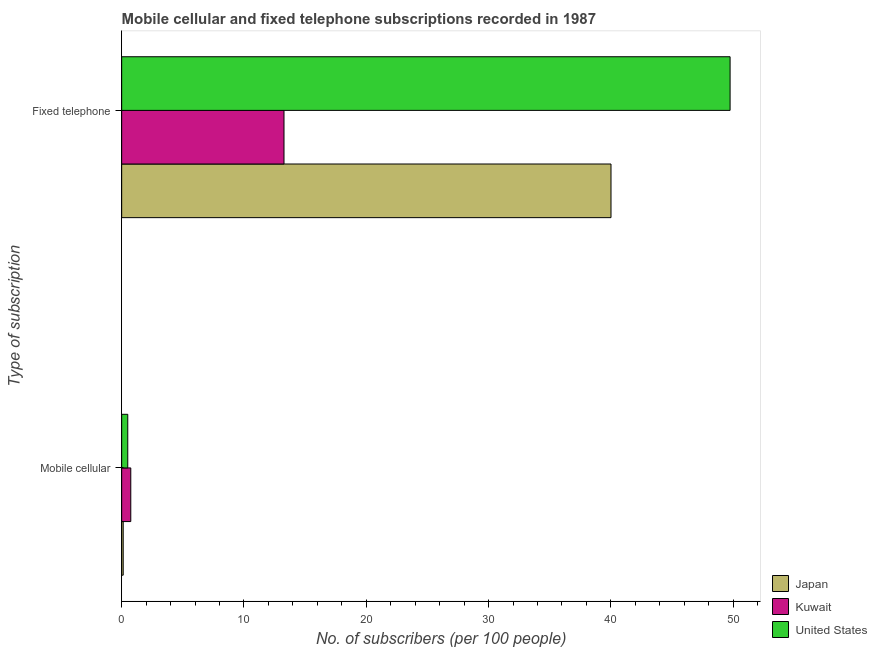How many different coloured bars are there?
Keep it short and to the point. 3. How many bars are there on the 1st tick from the bottom?
Your answer should be compact. 3. What is the label of the 1st group of bars from the top?
Make the answer very short. Fixed telephone. What is the number of mobile cellular subscribers in Kuwait?
Give a very brief answer. 0.74. Across all countries, what is the maximum number of mobile cellular subscribers?
Make the answer very short. 0.74. Across all countries, what is the minimum number of mobile cellular subscribers?
Your answer should be very brief. 0.12. In which country was the number of mobile cellular subscribers maximum?
Ensure brevity in your answer.  Kuwait. In which country was the number of fixed telephone subscribers minimum?
Keep it short and to the point. Kuwait. What is the total number of mobile cellular subscribers in the graph?
Your response must be concise. 1.37. What is the difference between the number of fixed telephone subscribers in Kuwait and that in United States?
Make the answer very short. -36.47. What is the difference between the number of mobile cellular subscribers in United States and the number of fixed telephone subscribers in Japan?
Your answer should be compact. -39.51. What is the average number of fixed telephone subscribers per country?
Keep it short and to the point. 34.34. What is the difference between the number of fixed telephone subscribers and number of mobile cellular subscribers in Kuwait?
Offer a terse response. 12.53. What is the ratio of the number of fixed telephone subscribers in Japan to that in Kuwait?
Provide a short and direct response. 3.01. What does the 2nd bar from the top in Fixed telephone represents?
Offer a terse response. Kuwait. What does the 3rd bar from the bottom in Fixed telephone represents?
Your answer should be compact. United States. How many bars are there?
Your answer should be very brief. 6. How many countries are there in the graph?
Offer a terse response. 3. What is the difference between two consecutive major ticks on the X-axis?
Keep it short and to the point. 10. How are the legend labels stacked?
Provide a short and direct response. Vertical. What is the title of the graph?
Your answer should be very brief. Mobile cellular and fixed telephone subscriptions recorded in 1987. Does "Indonesia" appear as one of the legend labels in the graph?
Offer a terse response. No. What is the label or title of the X-axis?
Provide a succinct answer. No. of subscribers (per 100 people). What is the label or title of the Y-axis?
Your answer should be compact. Type of subscription. What is the No. of subscribers (per 100 people) in Japan in Mobile cellular?
Keep it short and to the point. 0.12. What is the No. of subscribers (per 100 people) of Kuwait in Mobile cellular?
Offer a terse response. 0.74. What is the No. of subscribers (per 100 people) in United States in Mobile cellular?
Offer a very short reply. 0.5. What is the No. of subscribers (per 100 people) in Japan in Fixed telephone?
Offer a terse response. 40.01. What is the No. of subscribers (per 100 people) in Kuwait in Fixed telephone?
Ensure brevity in your answer.  13.27. What is the No. of subscribers (per 100 people) in United States in Fixed telephone?
Offer a very short reply. 49.75. Across all Type of subscription, what is the maximum No. of subscribers (per 100 people) in Japan?
Make the answer very short. 40.01. Across all Type of subscription, what is the maximum No. of subscribers (per 100 people) in Kuwait?
Your response must be concise. 13.27. Across all Type of subscription, what is the maximum No. of subscribers (per 100 people) of United States?
Give a very brief answer. 49.75. Across all Type of subscription, what is the minimum No. of subscribers (per 100 people) in Japan?
Your answer should be very brief. 0.12. Across all Type of subscription, what is the minimum No. of subscribers (per 100 people) in Kuwait?
Your answer should be very brief. 0.74. Across all Type of subscription, what is the minimum No. of subscribers (per 100 people) of United States?
Your response must be concise. 0.5. What is the total No. of subscribers (per 100 people) in Japan in the graph?
Provide a short and direct response. 40.13. What is the total No. of subscribers (per 100 people) of Kuwait in the graph?
Your answer should be very brief. 14.02. What is the total No. of subscribers (per 100 people) in United States in the graph?
Provide a succinct answer. 50.24. What is the difference between the No. of subscribers (per 100 people) of Japan in Mobile cellular and that in Fixed telephone?
Provide a short and direct response. -39.88. What is the difference between the No. of subscribers (per 100 people) in Kuwait in Mobile cellular and that in Fixed telephone?
Your answer should be compact. -12.53. What is the difference between the No. of subscribers (per 100 people) of United States in Mobile cellular and that in Fixed telephone?
Provide a succinct answer. -49.25. What is the difference between the No. of subscribers (per 100 people) in Japan in Mobile cellular and the No. of subscribers (per 100 people) in Kuwait in Fixed telephone?
Offer a terse response. -13.15. What is the difference between the No. of subscribers (per 100 people) in Japan in Mobile cellular and the No. of subscribers (per 100 people) in United States in Fixed telephone?
Keep it short and to the point. -49.62. What is the difference between the No. of subscribers (per 100 people) of Kuwait in Mobile cellular and the No. of subscribers (per 100 people) of United States in Fixed telephone?
Give a very brief answer. -49. What is the average No. of subscribers (per 100 people) in Japan per Type of subscription?
Your response must be concise. 20.07. What is the average No. of subscribers (per 100 people) of Kuwait per Type of subscription?
Your answer should be compact. 7.01. What is the average No. of subscribers (per 100 people) of United States per Type of subscription?
Make the answer very short. 25.12. What is the difference between the No. of subscribers (per 100 people) in Japan and No. of subscribers (per 100 people) in Kuwait in Mobile cellular?
Give a very brief answer. -0.62. What is the difference between the No. of subscribers (per 100 people) of Japan and No. of subscribers (per 100 people) of United States in Mobile cellular?
Make the answer very short. -0.37. What is the difference between the No. of subscribers (per 100 people) in Kuwait and No. of subscribers (per 100 people) in United States in Mobile cellular?
Make the answer very short. 0.25. What is the difference between the No. of subscribers (per 100 people) of Japan and No. of subscribers (per 100 people) of Kuwait in Fixed telephone?
Provide a succinct answer. 26.74. What is the difference between the No. of subscribers (per 100 people) of Japan and No. of subscribers (per 100 people) of United States in Fixed telephone?
Make the answer very short. -9.74. What is the difference between the No. of subscribers (per 100 people) in Kuwait and No. of subscribers (per 100 people) in United States in Fixed telephone?
Offer a very short reply. -36.47. What is the ratio of the No. of subscribers (per 100 people) in Japan in Mobile cellular to that in Fixed telephone?
Ensure brevity in your answer.  0. What is the ratio of the No. of subscribers (per 100 people) of Kuwait in Mobile cellular to that in Fixed telephone?
Your answer should be very brief. 0.06. What is the difference between the highest and the second highest No. of subscribers (per 100 people) of Japan?
Provide a short and direct response. 39.88. What is the difference between the highest and the second highest No. of subscribers (per 100 people) in Kuwait?
Offer a terse response. 12.53. What is the difference between the highest and the second highest No. of subscribers (per 100 people) in United States?
Give a very brief answer. 49.25. What is the difference between the highest and the lowest No. of subscribers (per 100 people) in Japan?
Your answer should be very brief. 39.88. What is the difference between the highest and the lowest No. of subscribers (per 100 people) of Kuwait?
Your response must be concise. 12.53. What is the difference between the highest and the lowest No. of subscribers (per 100 people) of United States?
Your answer should be compact. 49.25. 